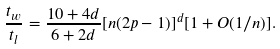<formula> <loc_0><loc_0><loc_500><loc_500>\frac { t _ { w } } { t _ { l } } = \frac { 1 0 + 4 d } { 6 + 2 d } [ n ( 2 p - 1 ) ] ^ { d } [ 1 + O ( 1 / n ) ] .</formula> 